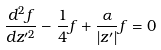Convert formula to latex. <formula><loc_0><loc_0><loc_500><loc_500>\frac { d ^ { 2 } f } { d z ^ { \prime 2 } } - \frac { 1 } { 4 } f + \frac { \alpha } { \left | z ^ { \prime } \right | } f = 0</formula> 